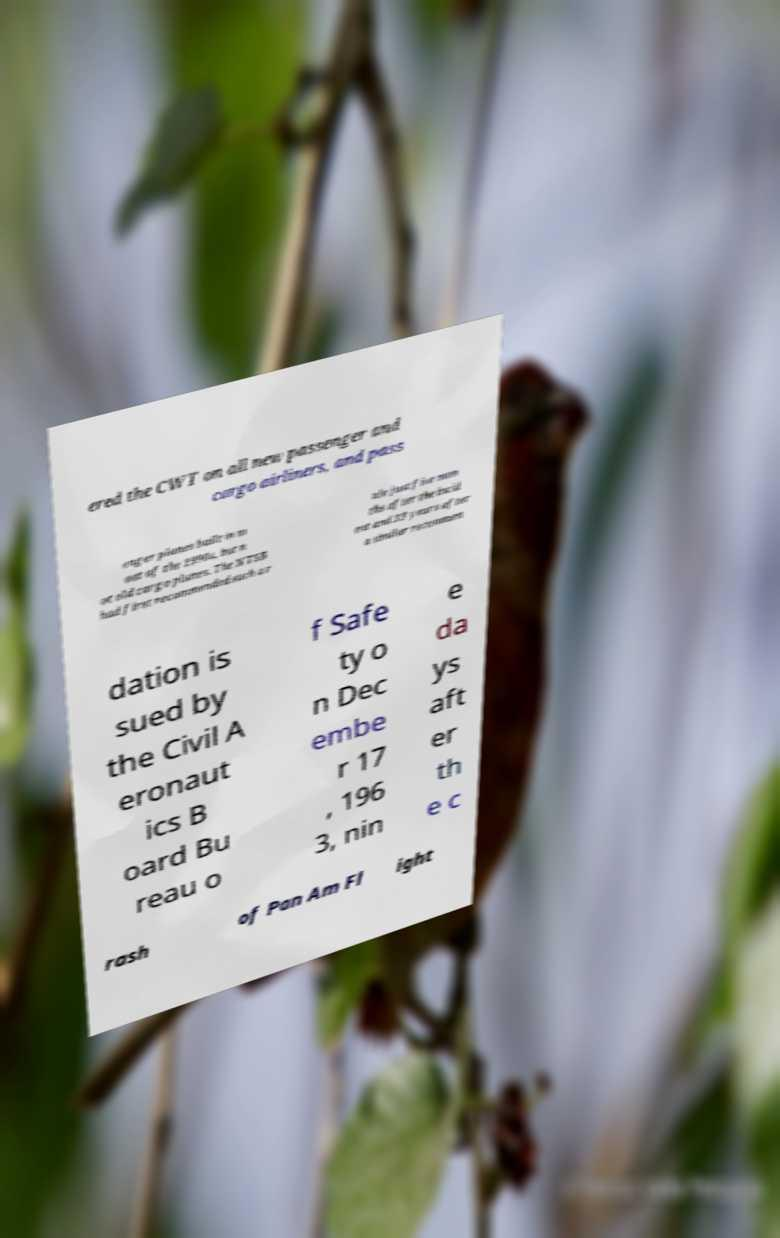Could you extract and type out the text from this image? ered the CWT on all new passenger and cargo airliners, and pass enger planes built in m ost of the 1990s, but n ot old cargo planes. The NTSB had first recommended such a r ule just five mon ths after the incid ent and 33 years after a similar recommen dation is sued by the Civil A eronaut ics B oard Bu reau o f Safe ty o n Dec embe r 17 , 196 3, nin e da ys aft er th e c rash of Pan Am Fl ight 